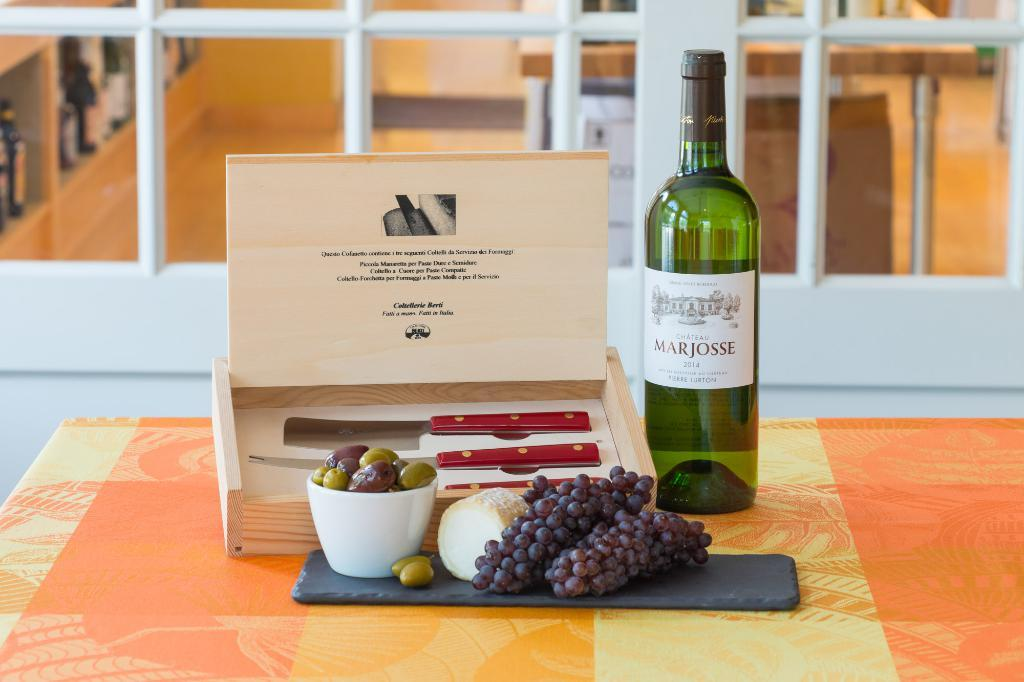<image>
Offer a succinct explanation of the picture presented. Alcohol bottle with a white label that says Marjosse on it. 